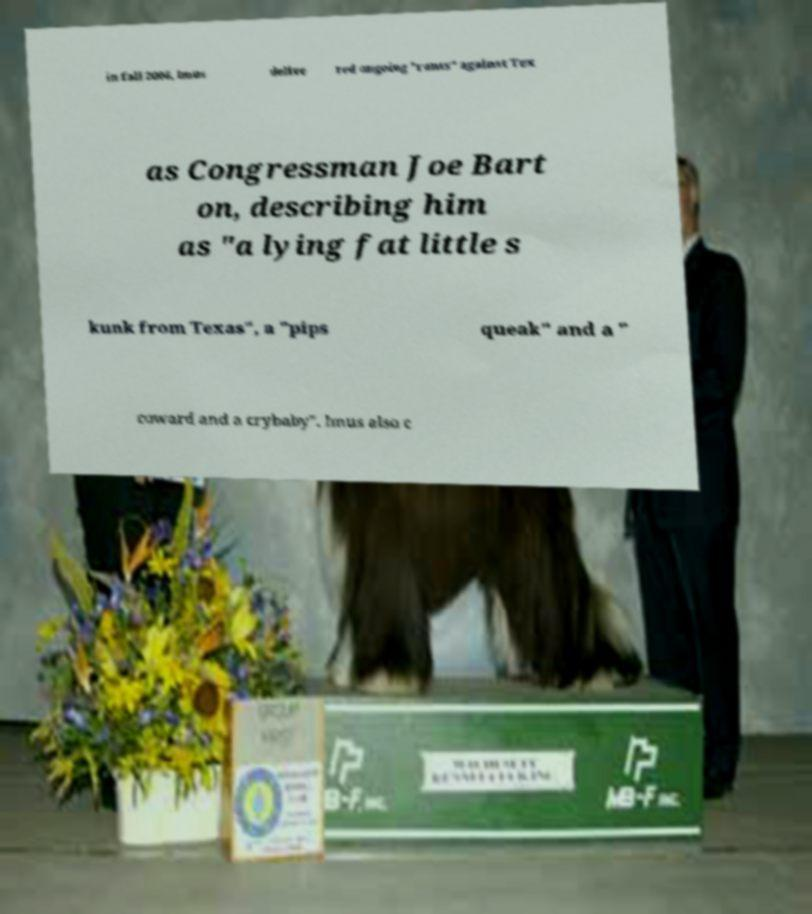Can you accurately transcribe the text from the provided image for me? in fall 2006, Imus delive red ongoing "rants" against Tex as Congressman Joe Bart on, describing him as "a lying fat little s kunk from Texas", a "pips queak" and a " coward and a crybaby". Imus also c 